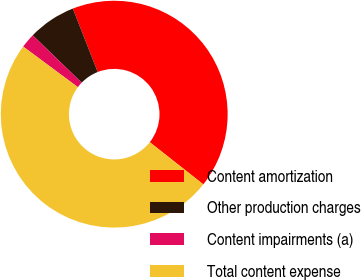Convert chart. <chart><loc_0><loc_0><loc_500><loc_500><pie_chart><fcel>Content amortization<fcel>Other production charges<fcel>Content impairments (a)<fcel>Total content expense<nl><fcel>41.57%<fcel>6.82%<fcel>2.07%<fcel>49.54%<nl></chart> 